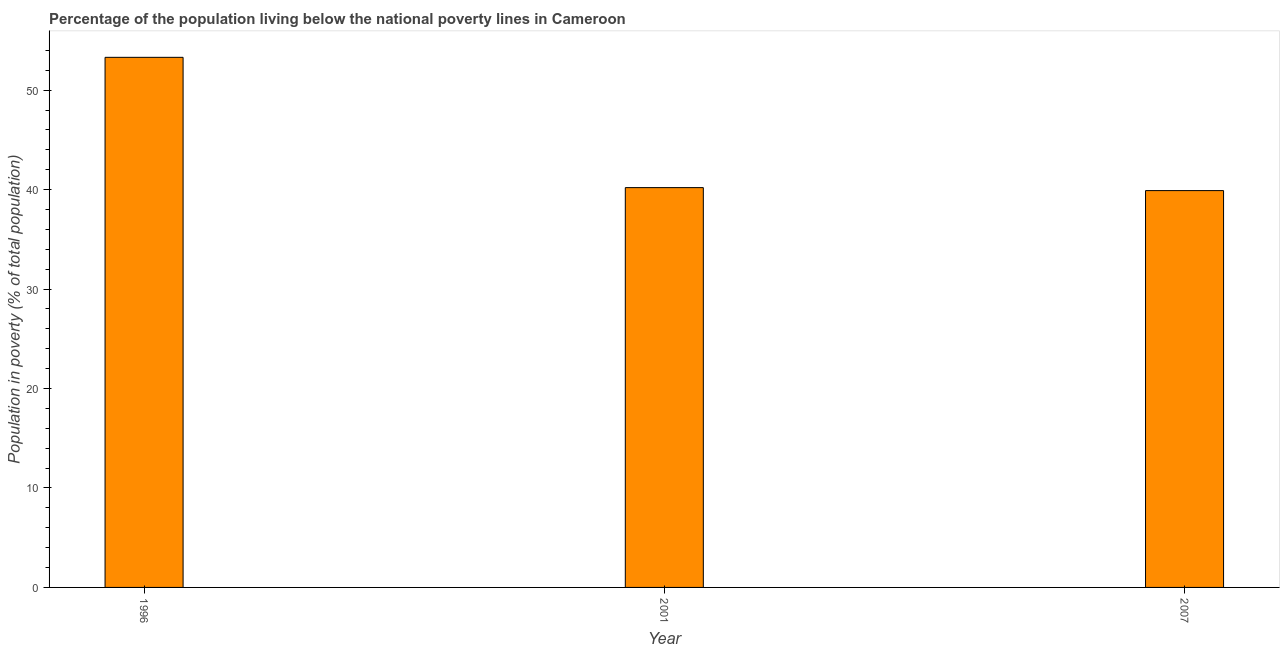Does the graph contain any zero values?
Keep it short and to the point. No. What is the title of the graph?
Offer a very short reply. Percentage of the population living below the national poverty lines in Cameroon. What is the label or title of the X-axis?
Keep it short and to the point. Year. What is the label or title of the Y-axis?
Ensure brevity in your answer.  Population in poverty (% of total population). What is the percentage of population living below poverty line in 2001?
Offer a terse response. 40.2. Across all years, what is the maximum percentage of population living below poverty line?
Ensure brevity in your answer.  53.3. Across all years, what is the minimum percentage of population living below poverty line?
Make the answer very short. 39.9. In which year was the percentage of population living below poverty line maximum?
Keep it short and to the point. 1996. What is the sum of the percentage of population living below poverty line?
Offer a terse response. 133.4. What is the difference between the percentage of population living below poverty line in 1996 and 2001?
Offer a very short reply. 13.1. What is the average percentage of population living below poverty line per year?
Offer a terse response. 44.47. What is the median percentage of population living below poverty line?
Keep it short and to the point. 40.2. In how many years, is the percentage of population living below poverty line greater than 52 %?
Your answer should be compact. 1. Do a majority of the years between 2007 and 1996 (inclusive) have percentage of population living below poverty line greater than 20 %?
Provide a succinct answer. Yes. What is the ratio of the percentage of population living below poverty line in 1996 to that in 2001?
Offer a terse response. 1.33. Is the sum of the percentage of population living below poverty line in 1996 and 2001 greater than the maximum percentage of population living below poverty line across all years?
Give a very brief answer. Yes. What is the difference between the highest and the lowest percentage of population living below poverty line?
Offer a very short reply. 13.4. How many years are there in the graph?
Make the answer very short. 3. What is the Population in poverty (% of total population) in 1996?
Provide a succinct answer. 53.3. What is the Population in poverty (% of total population) in 2001?
Your response must be concise. 40.2. What is the Population in poverty (% of total population) of 2007?
Provide a succinct answer. 39.9. What is the difference between the Population in poverty (% of total population) in 1996 and 2007?
Provide a succinct answer. 13.4. What is the ratio of the Population in poverty (% of total population) in 1996 to that in 2001?
Ensure brevity in your answer.  1.33. What is the ratio of the Population in poverty (% of total population) in 1996 to that in 2007?
Make the answer very short. 1.34. 